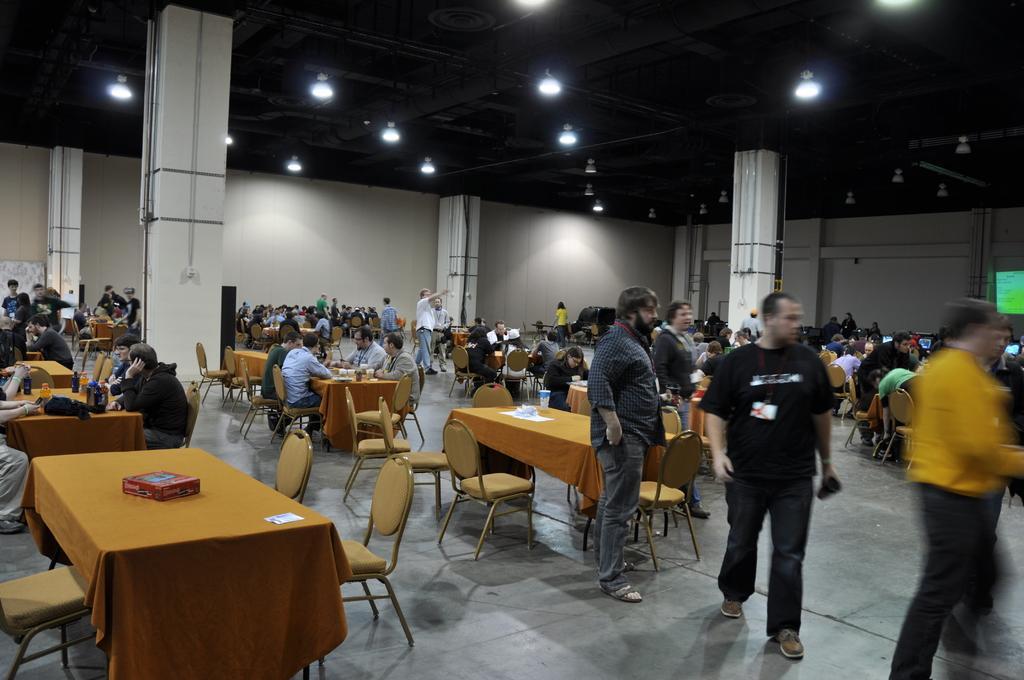Describe this image in one or two sentences. Here we can see a group of guys sitting on chairs with tables in front of them and there are also guys standing and there are lights at the top 